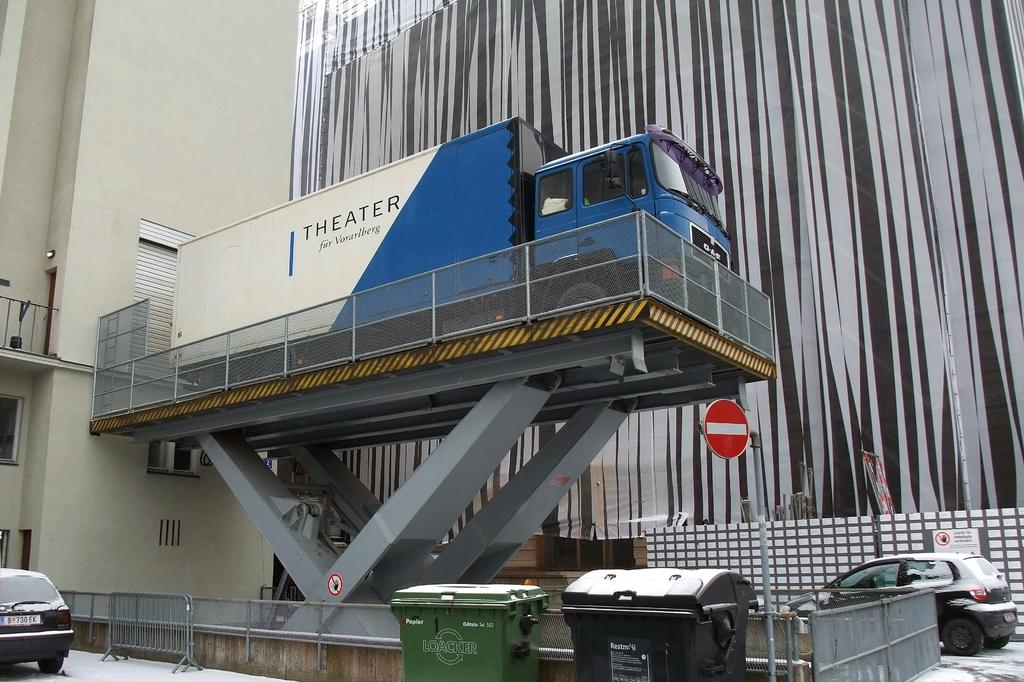<image>
Provide a brief description of the given image. A blue and white THEATER truck sits on top of a loading platform 